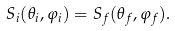<formula> <loc_0><loc_0><loc_500><loc_500>S _ { i } ( \theta _ { i } , \varphi _ { i } ) = S _ { f } ( \theta _ { f } , \varphi _ { f } ) .</formula> 